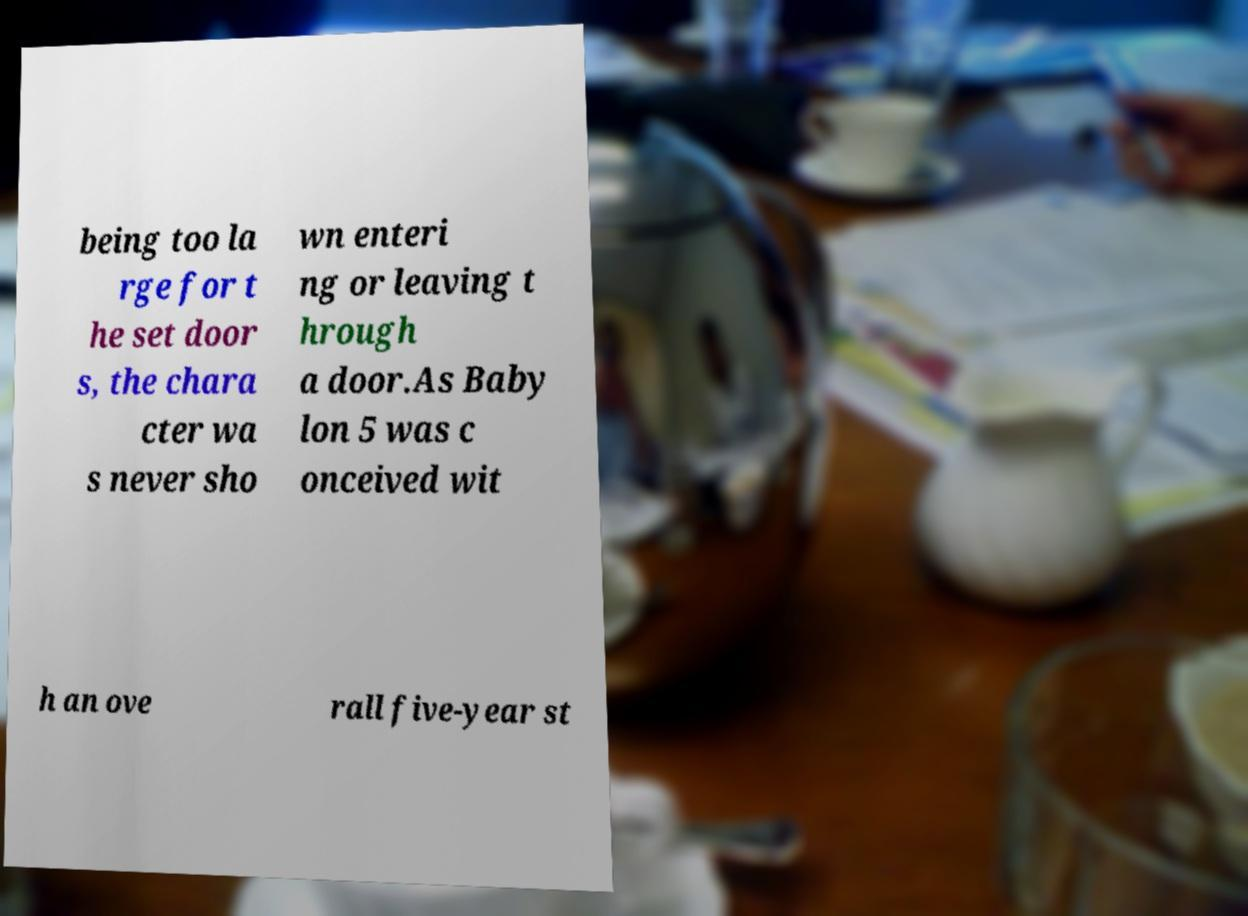Can you accurately transcribe the text from the provided image for me? being too la rge for t he set door s, the chara cter wa s never sho wn enteri ng or leaving t hrough a door.As Baby lon 5 was c onceived wit h an ove rall five-year st 